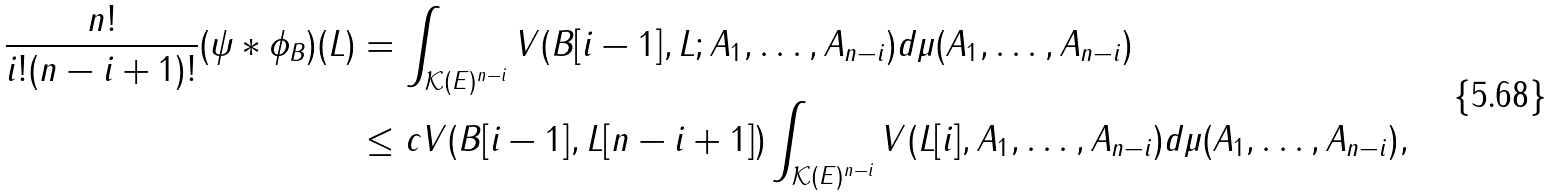<formula> <loc_0><loc_0><loc_500><loc_500>\frac { n ! } { i ! ( n - i + 1 ) ! } ( \psi * \phi _ { B } ) ( L ) & = \int _ { \mathcal { K } ( E ) ^ { n - i } } V ( B [ i - 1 ] , L ; A _ { 1 } , \dots , A _ { n - i } ) d \mu ( A _ { 1 } , \dots , A _ { n - i } ) \\ & \leq c V ( B [ i - 1 ] , L [ n - i + 1 ] ) \int _ { \mathcal { K } ( E ) ^ { n - i } } V ( L [ i ] , A _ { 1 } , \dots , A _ { n - i } ) d \mu ( A _ { 1 } , \dots , A _ { n - i } ) ,</formula> 